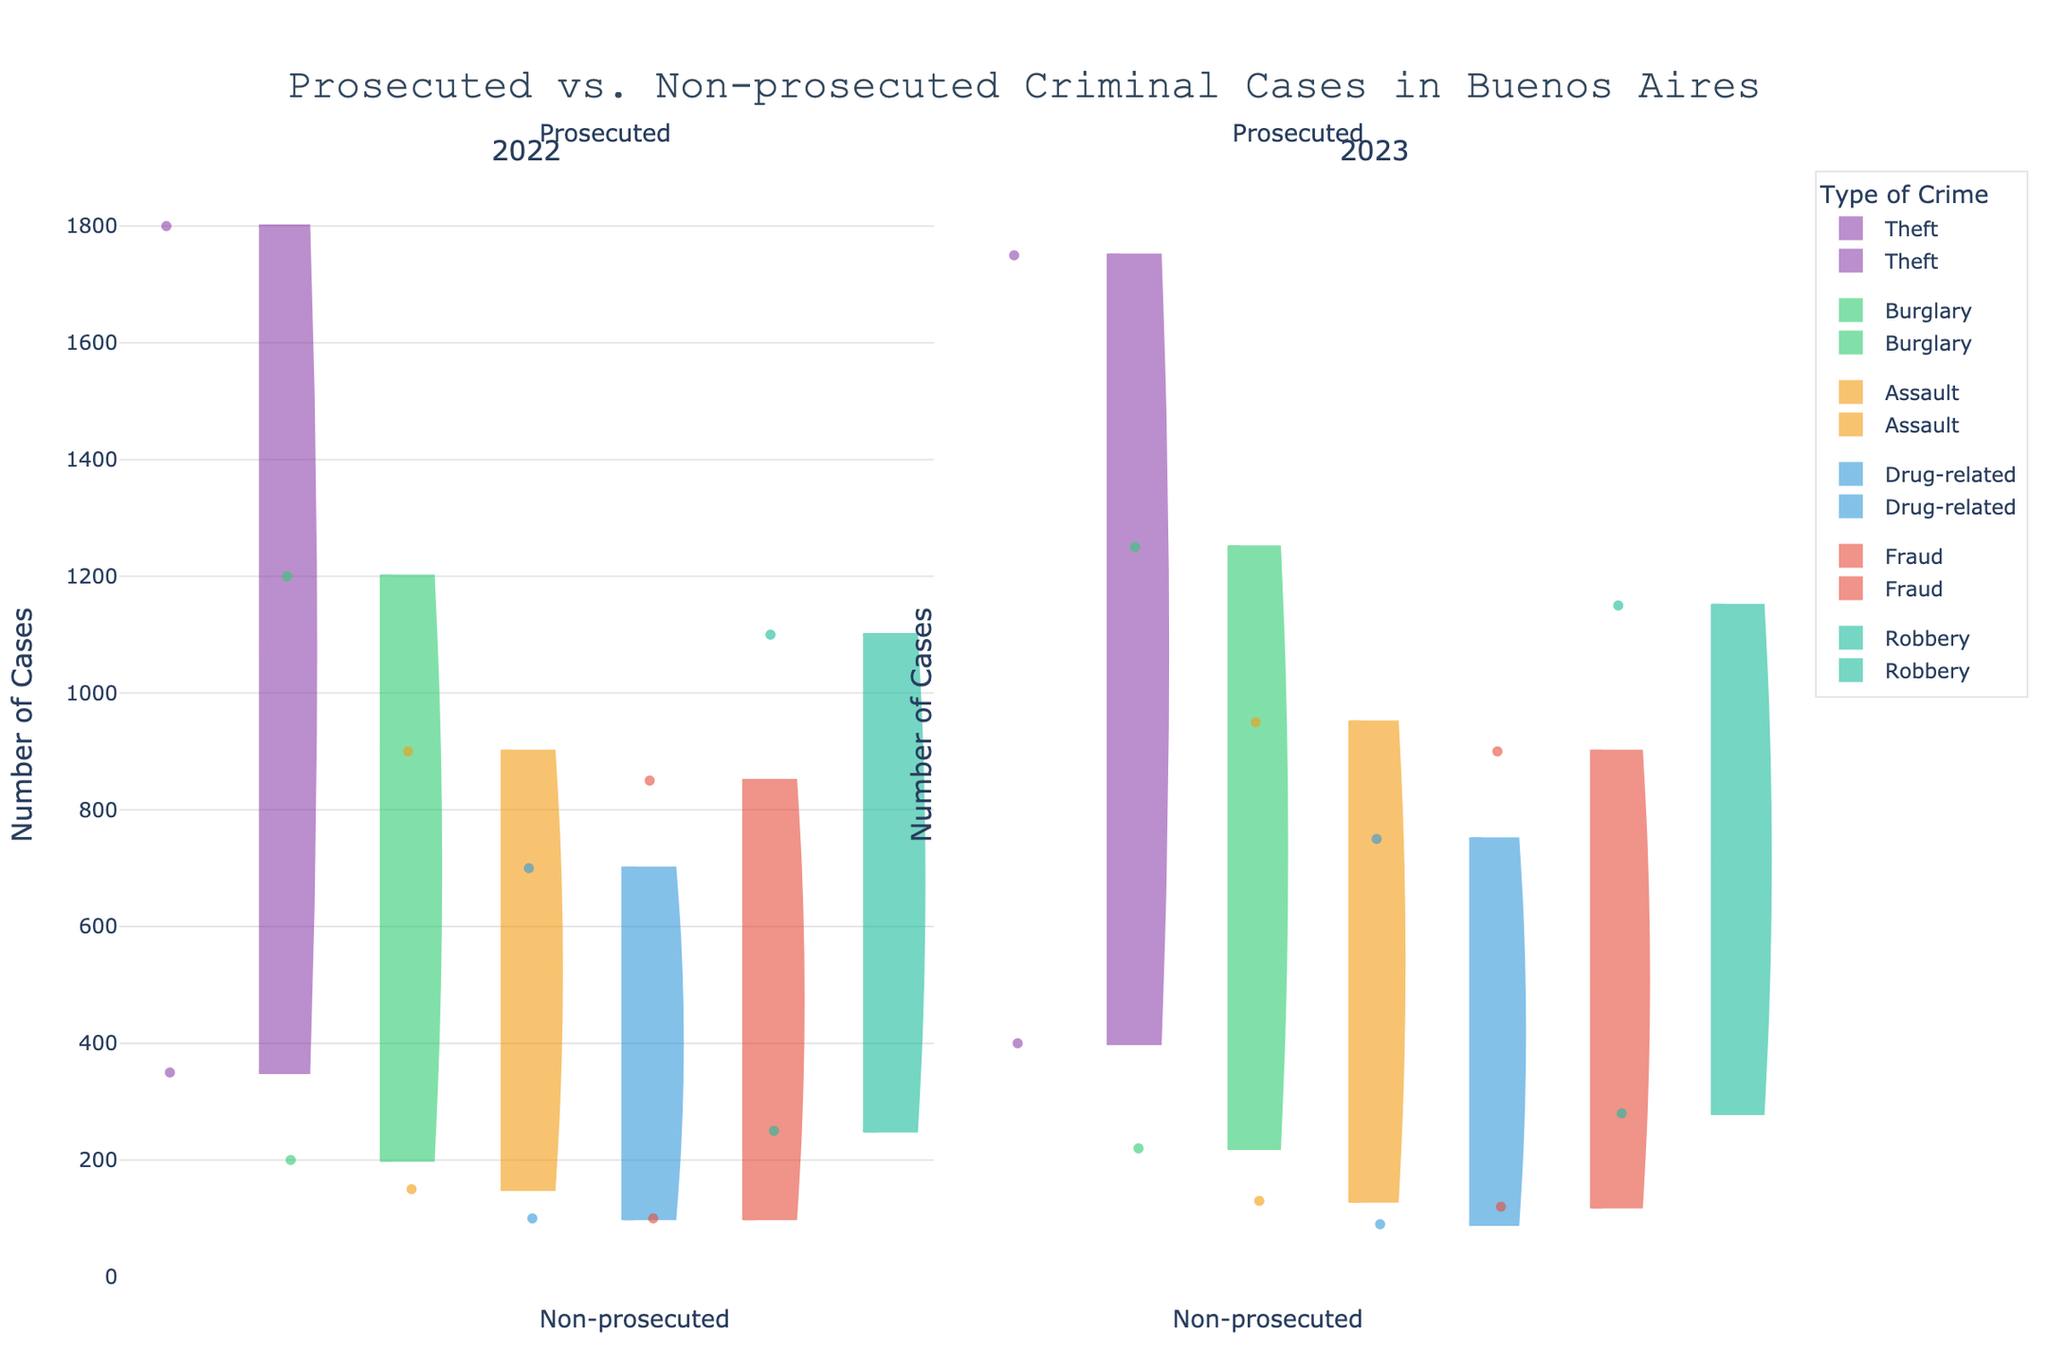What types of crimes are included in the visualization? The visualization includes different types of criminal cases prosecuted and non-prosecuted. We can see crime categories labeled on the x-axis.
Answer: Theft, Burglary, Assault, Drug-related, Fraud, Robbery How does the total count of prosecuted Theft cases in 2022 compare to that in 2023? We look at the top side of the split violin for Theft in both subplots (2022 and 2023) and read the count values provided. In 2022, the prosecuted Theft count is 1800, and in 2023, it is 1750.
Answer: 1800 (2022) vs. 1750 (2023) Which type of crime has the least non-prosecuted cases in 2023? We observe the bottom side of the split violins for 2023 and check the counts. By comparing the counts, Drug-related crime has the least non-prosecuted cases with a count of 90.
Answer: Drug-related Which year saw a higher number of prosecuted Burglary cases, and by how much? We compare the prosecuted counts for Burglary in the split violins for 2022 and 2023. In 2022, the count is 1200, and in 2023, it is 1250. The difference is 1250 - 1200 = 50.
Answer: 2023 by 50 What is the average count of non-prosecuted Robbery cases over both years? We see the non-prosecuted counts for Robbery (bottom side) in 2022 (250) and 2023 (280). The average count is calculated as (250 + 280) / 2 = 265.
Answer: 265 How do the prosecuted cases of Fraud compare between 2022 and 2023? Observing the top side of the split violin for Fraud in both years, Fraud cases were 850 in 2022 and 900 in 2023.
Answer: Higher in 2023 Which type of crime consistently has a higher proportion of prosecuted cases over both years? We need to analyze each crime type's prosecuted and non-prosecuted cases visually. For every crime, compare the top (prosecuted) and bottom (non-prosecuted) counts across both years. Assault stands out with a notably higher portion of prosecuted cases in both years.
Answer: Assault Are there any types of crimes with an increase in both prosecuted and non-prosecuted cases from 2022 to 2023? By visually comparing the split violins for each crime type across both years, we find that Theft and Robbery have increases in both prosecuted and non-prosecuted cases.
Answer: Theft and Robbery 